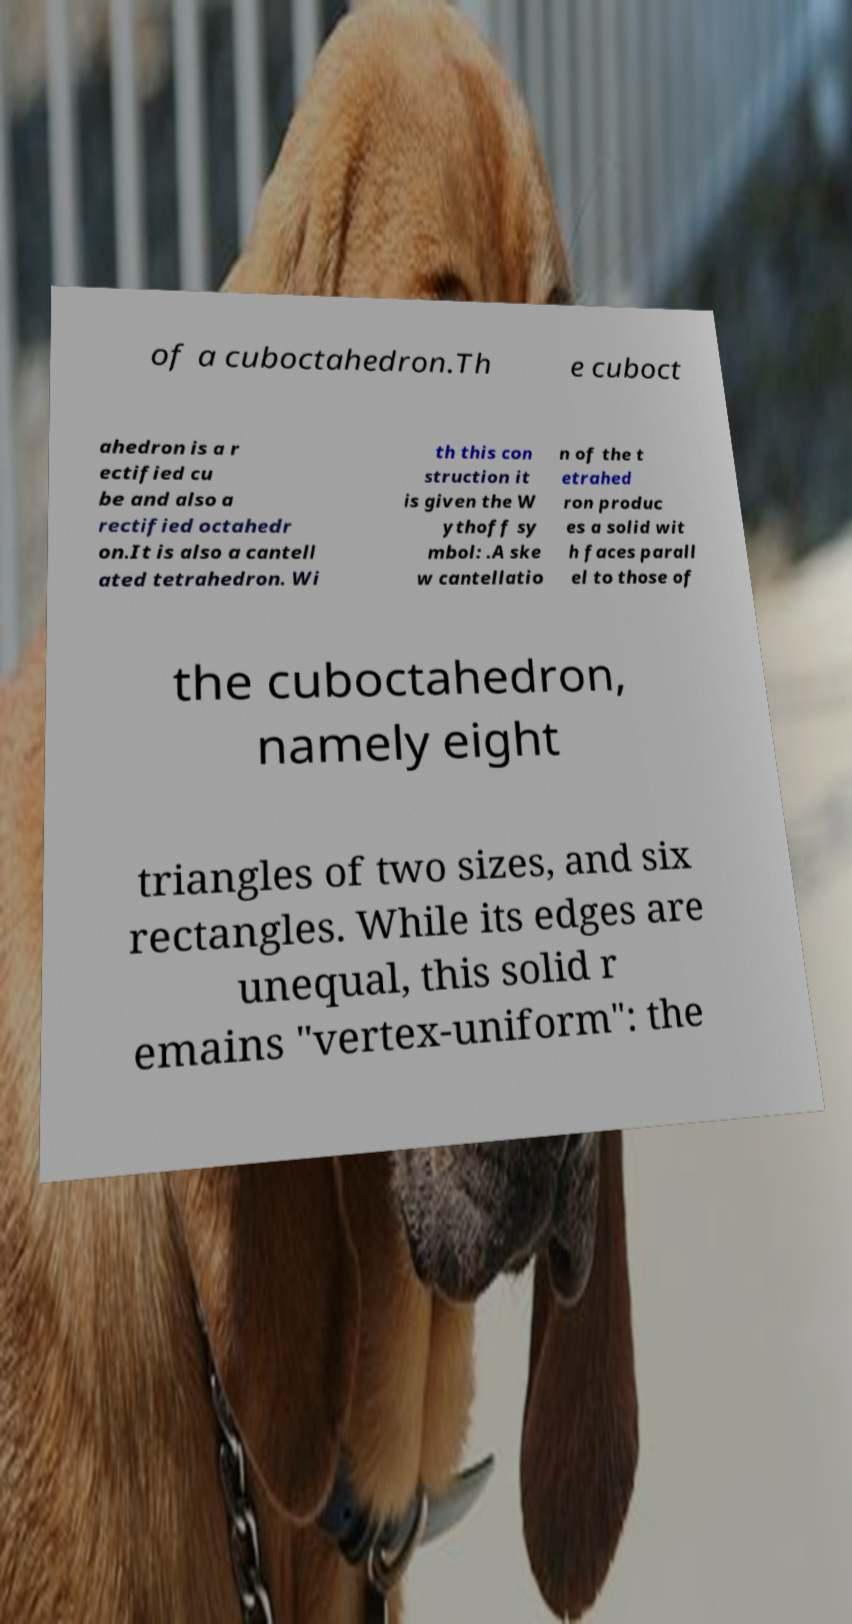Please identify and transcribe the text found in this image. of a cuboctahedron.Th e cuboct ahedron is a r ectified cu be and also a rectified octahedr on.It is also a cantell ated tetrahedron. Wi th this con struction it is given the W ythoff sy mbol: .A ske w cantellatio n of the t etrahed ron produc es a solid wit h faces parall el to those of the cuboctahedron, namely eight triangles of two sizes, and six rectangles. While its edges are unequal, this solid r emains "vertex-uniform": the 